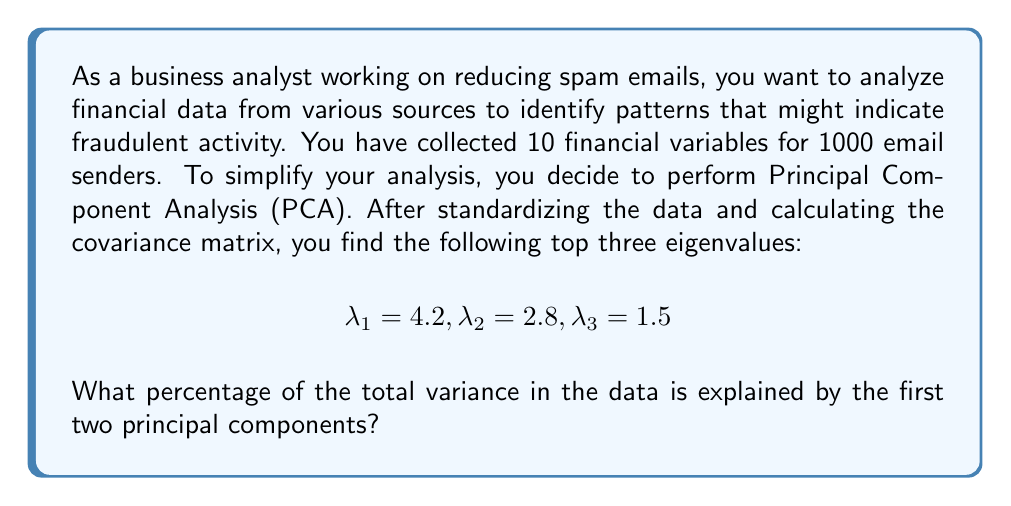Could you help me with this problem? To solve this problem, we need to follow these steps:

1. Understand what the eigenvalues represent in PCA:
   Each eigenvalue represents the amount of variance explained by its corresponding principal component.

2. Calculate the total variance:
   The total variance is the sum of all eigenvalues. In this case, we're given only the top three, but we know there are 10 variables in total. However, we can solve the problem using just the information provided.

3. Calculate the variance explained by the first two principal components:
   $$\text{Variance explained} = \lambda_1 + \lambda_2 = 4.2 + 2.8 = 7.0$$

4. Calculate the percentage of variance explained:
   $$\text{Percentage} = \frac{\text{Variance explained by first two PCs}}{\text{Total variance of first three PCs}} \times 100\%$$
   
   $$= \frac{7.0}{4.2 + 2.8 + 1.5} \times 100\% = \frac{7.0}{8.5} \times 100\% \approx 82.35\%$$

Note that this is a lower bound on the actual percentage, as we're not considering the remaining eigenvalues, which would increase the denominator and thus decrease the percentage slightly.
Answer: The first two principal components explain approximately 82.35% of the total variance in the data (based on the information provided for the top three eigenvalues). 